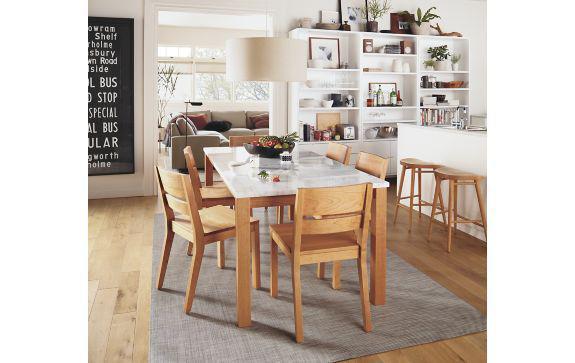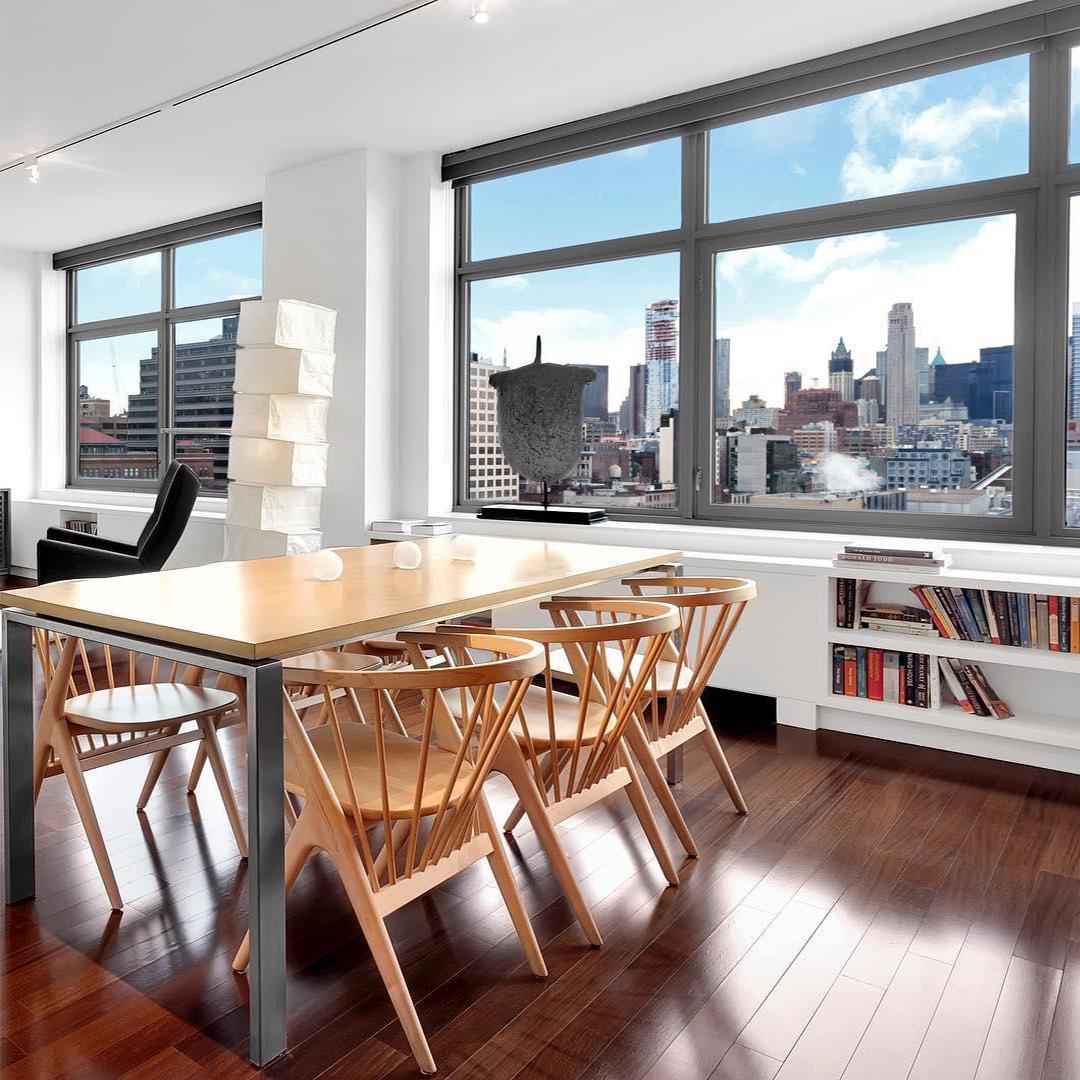The first image is the image on the left, the second image is the image on the right. For the images shown, is this caption "A dining set features a dark table top and four-legged chairs with solid, monochrome backs and seats." true? Answer yes or no. No. The first image is the image on the left, the second image is the image on the right. For the images displayed, is the sentence "There is a white hanging lamp over the table in at least one of the images." factually correct? Answer yes or no. Yes. 